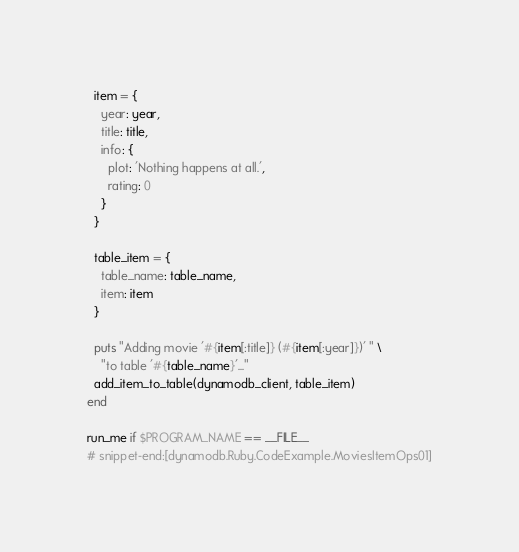Convert code to text. <code><loc_0><loc_0><loc_500><loc_500><_Ruby_>  item = {
    year: year,
    title: title,
    info: {
      plot: 'Nothing happens at all.',
      rating: 0
    }
  }

  table_item = {
    table_name: table_name,
    item: item
  }

  puts "Adding movie '#{item[:title]} (#{item[:year]})' " \
    "to table '#{table_name}'..."
  add_item_to_table(dynamodb_client, table_item)
end

run_me if $PROGRAM_NAME == __FILE__
# snippet-end:[dynamodb.Ruby.CodeExample.MoviesItemOps01]
</code> 